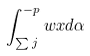Convert formula to latex. <formula><loc_0><loc_0><loc_500><loc_500>\int _ { \sum { j } } ^ { - p } { w x } d \alpha</formula> 